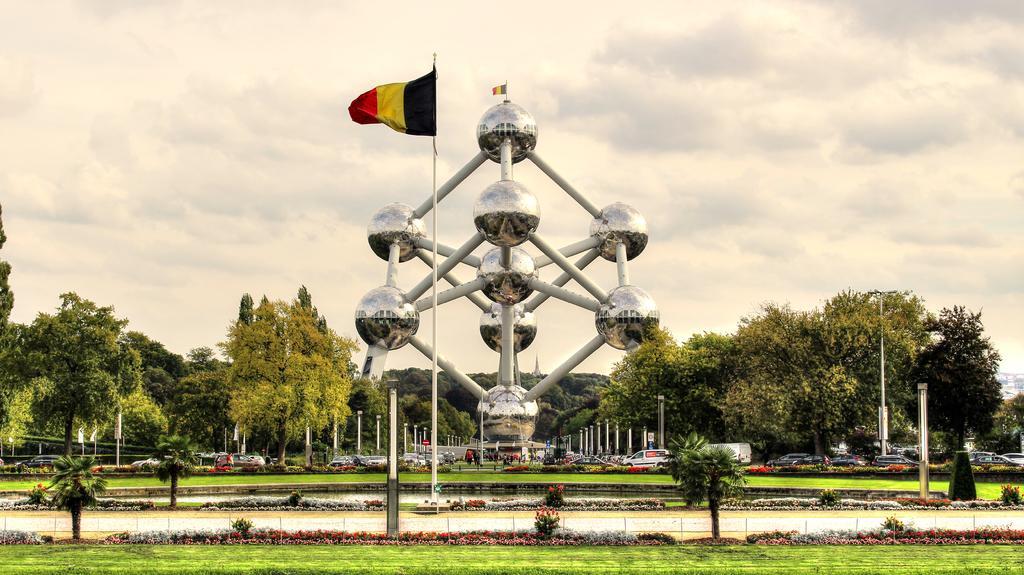Could you give a brief overview of what you see in this image? In the center of the image we can see an Atomium and the flag on it. We can also see some people and a group of vehicles on the ground. We can also see a group of trees, water, plants with flowers, grass, some poles, a fence, the flag to a pole, the boards and the sky which looks cloudy. 